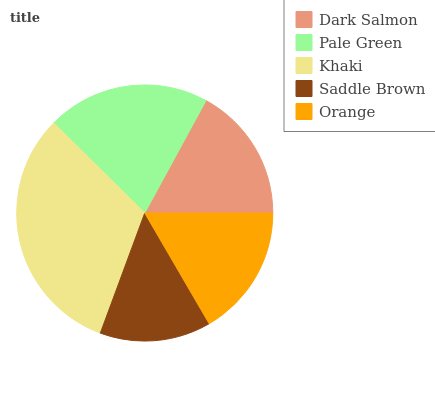Is Saddle Brown the minimum?
Answer yes or no. Yes. Is Khaki the maximum?
Answer yes or no. Yes. Is Pale Green the minimum?
Answer yes or no. No. Is Pale Green the maximum?
Answer yes or no. No. Is Pale Green greater than Dark Salmon?
Answer yes or no. Yes. Is Dark Salmon less than Pale Green?
Answer yes or no. Yes. Is Dark Salmon greater than Pale Green?
Answer yes or no. No. Is Pale Green less than Dark Salmon?
Answer yes or no. No. Is Dark Salmon the high median?
Answer yes or no. Yes. Is Dark Salmon the low median?
Answer yes or no. Yes. Is Orange the high median?
Answer yes or no. No. Is Saddle Brown the low median?
Answer yes or no. No. 